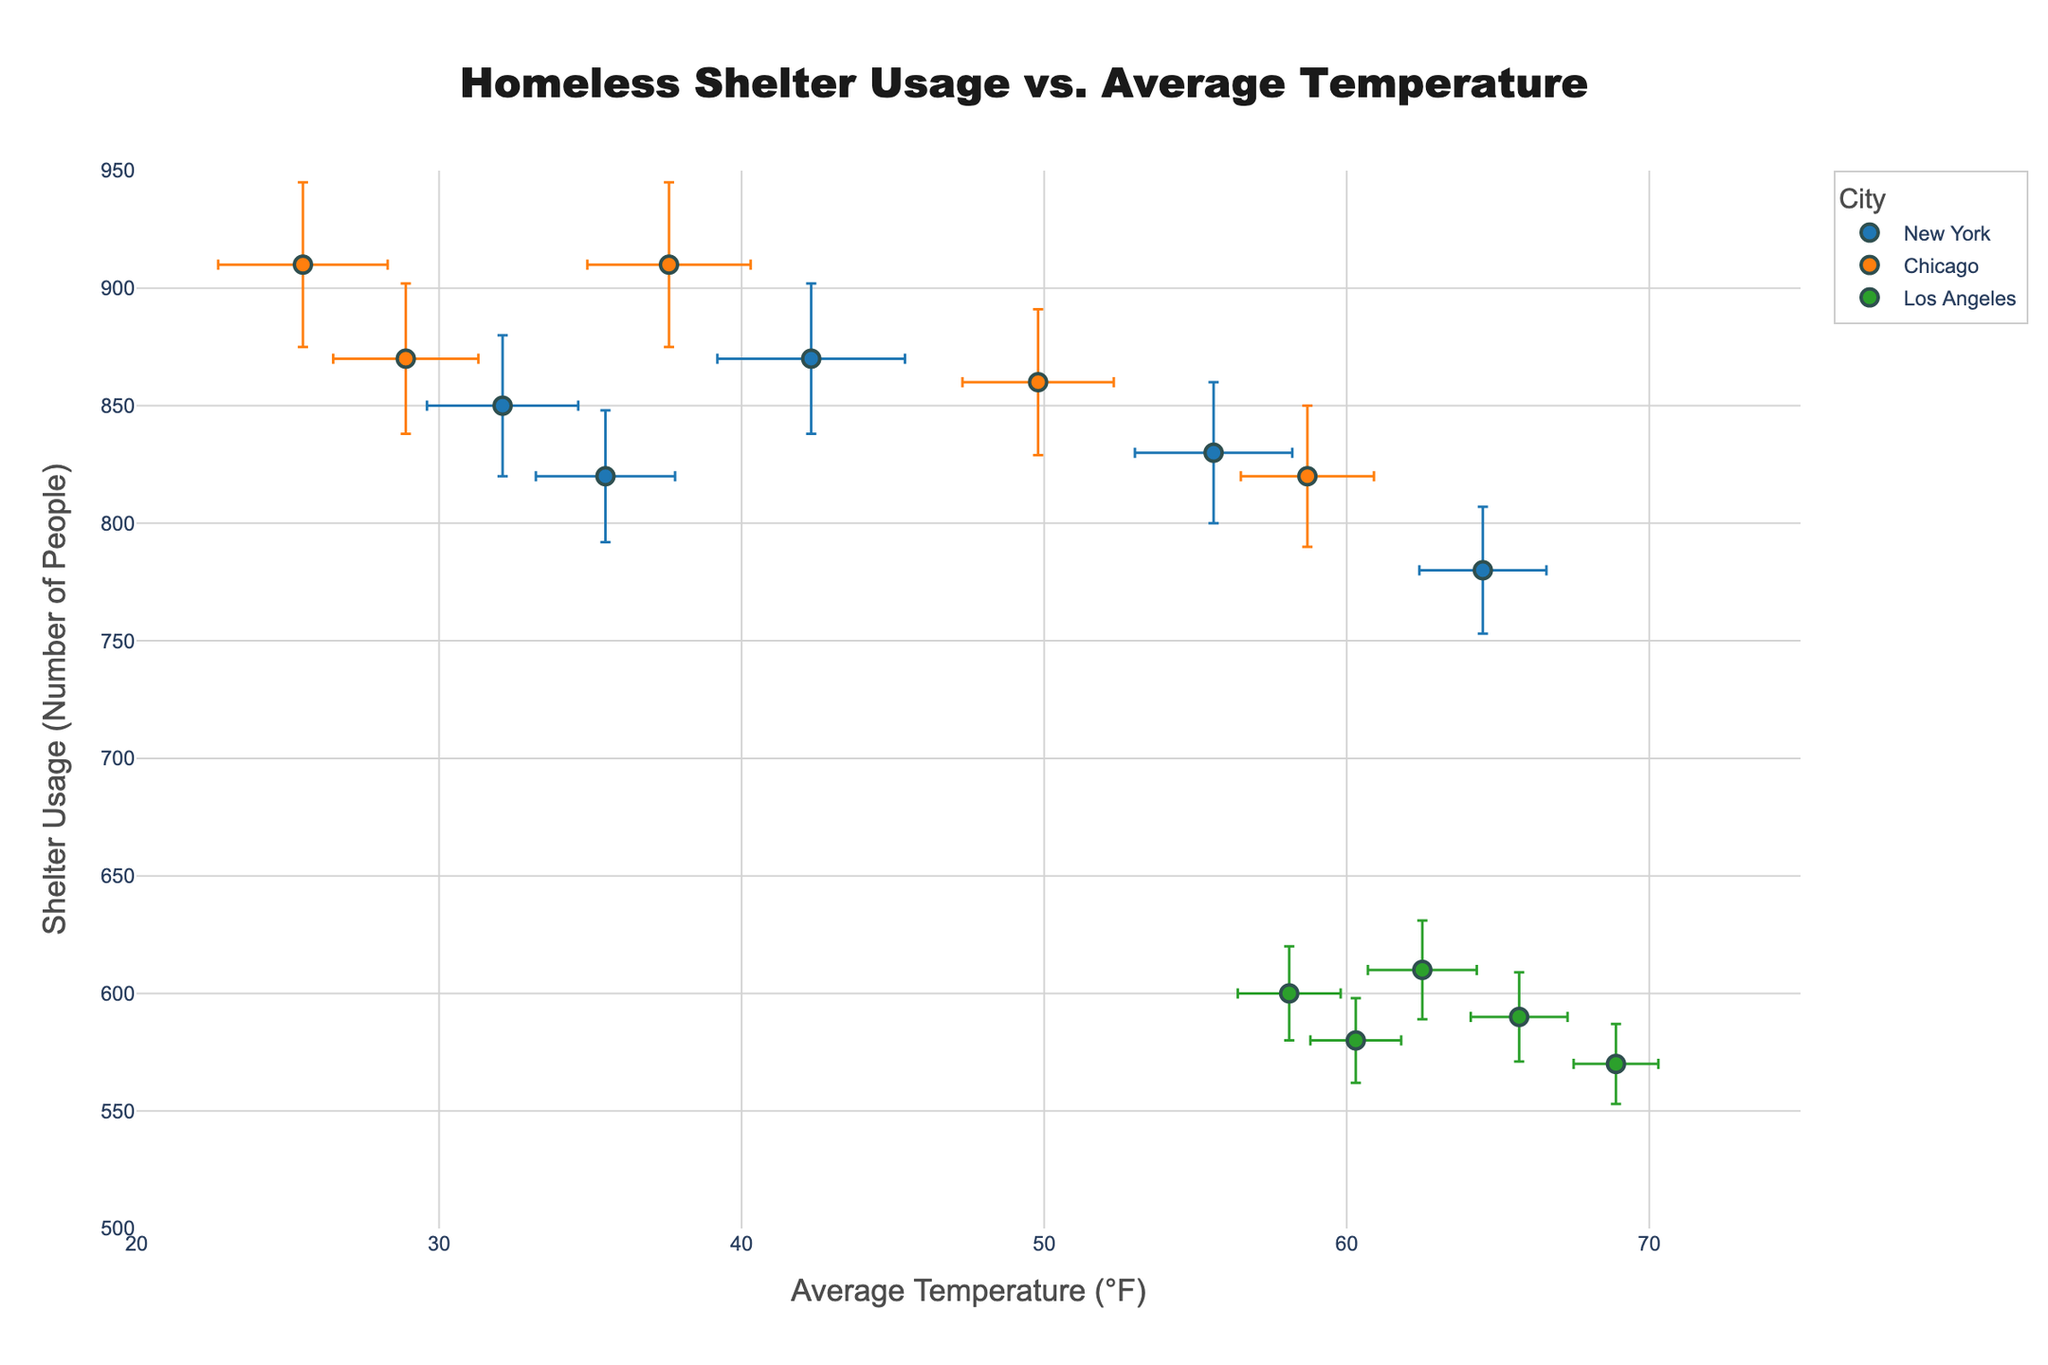What is the title of the figure? The title is usually positioned at the top of the figure. In this case, the title is written in a clear, large font so it's easy to read.
Answer: Homeless Shelter Usage vs. Average Temperature How many cities are represented in the scatter plot? The legend usually indicates the categories being represented. Here, the legend shows three different cities with unique colors.
Answer: 3 Which city appears to have the highest average temperature? Check the horizontal axis labeled as "Average Temperature (°F)" and identify the city with the highest x-coordinate point.
Answer: Los Angeles How does shelter usage change with temperature in New York? Observe the trend of data points for New York from left to right along the temperature axis, noting whether shelter usage increases or decreases.
Answer: It generally decreases as temperature increases Which city has the lowest overall shelter usage? Compare the data points on the vertical axis labeled "Shelter Usage (Number of People)" for each city, focusing on the lowest points.
Answer: Los Angeles What is the average shelter usage in Chicago for the months shown? Sum the shelter usage values for Chicago and divide by the number of months (data points for Chicago). (910 + 870 + 910 + 860 + 820) = 4370 / 5
Answer: 874 Which city shows the largest variation in shelter usage? Compare the error bars representing standard error of shelter usage for each city and see which one visibly has the longest bars.
Answer: Chicago In which month did New York have the highest shelter usage and what was the temperature during that month? Identify the data point with the highest shelter usage for New York, then match it with the corresponding average temperature value on the same plot.
Answer: March, 42.3°F Does any city show an increasing trend in shelter usage with increasing temperature? Observe the scatter plots for each city and ascertain whether the trend lines are upward as the temperature increases.
Answer: No Which city has the smallest standard error in temperature measurements? Compare the length of the horizontal error bars (standard error of temperature) for each city to identify which is shortest.
Answer: Los Angeles 